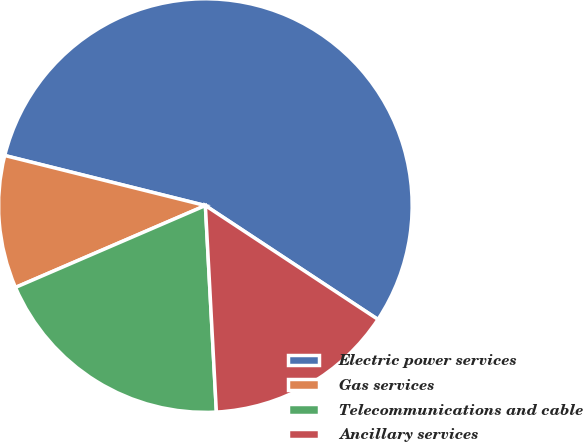Convert chart. <chart><loc_0><loc_0><loc_500><loc_500><pie_chart><fcel>Electric power services<fcel>Gas services<fcel>Telecommunications and cable<fcel>Ancillary services<nl><fcel>55.39%<fcel>10.37%<fcel>19.37%<fcel>14.87%<nl></chart> 